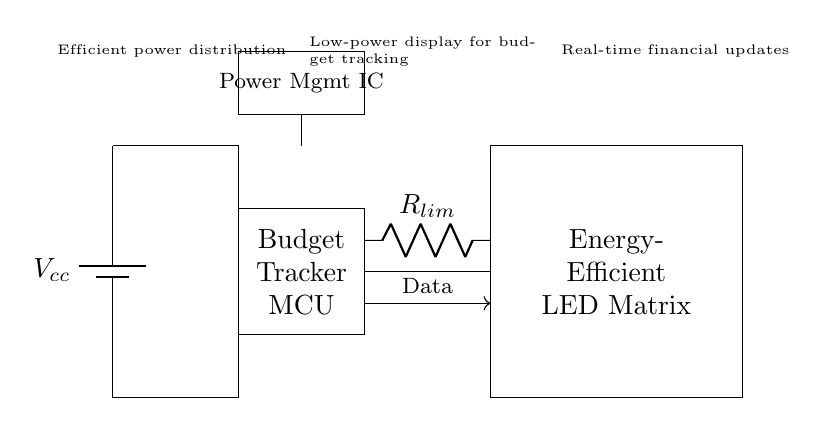What is the power supply component in this circuit? The power supply component is a battery, marked as V_cc, which provides the necessary voltage to the circuit.
Answer: Battery What does the abbreviation MCU stand for in the circuit diagram? The abbreviation MCU stands for Microcontroller Unit, which is responsible for managing the budget tracking functionality in the circuit.
Answer: Microcontroller Unit How many components are in the circuit? The circuit consists of four main components: a battery, a microcontroller, an LED matrix, and a current limiting resistor.
Answer: Four What is the purpose of the Power Management IC? The Power Management IC regulates power distribution to ensure efficient energy use in the circuit, supporting low-power operations while maintaining functionality.
Answer: Efficient power distribution What type of display is shown in this circuit? The circuit features an energy-efficient LED matrix display, which is designed for real-time budget tracking with minimal power consumption.
Answer: Energy-efficient LED matrix What type of resistor is used in this circuit? A current limiting resistor is used in the circuit to restrict the flow of current, preventing damage to the LED matrix.
Answer: Current limiting resistor What kind of data does the microcontroller receive? The microcontroller receives data necessary for real-time financial updates, which it processes to control the LED display accordingly.
Answer: Financial data 